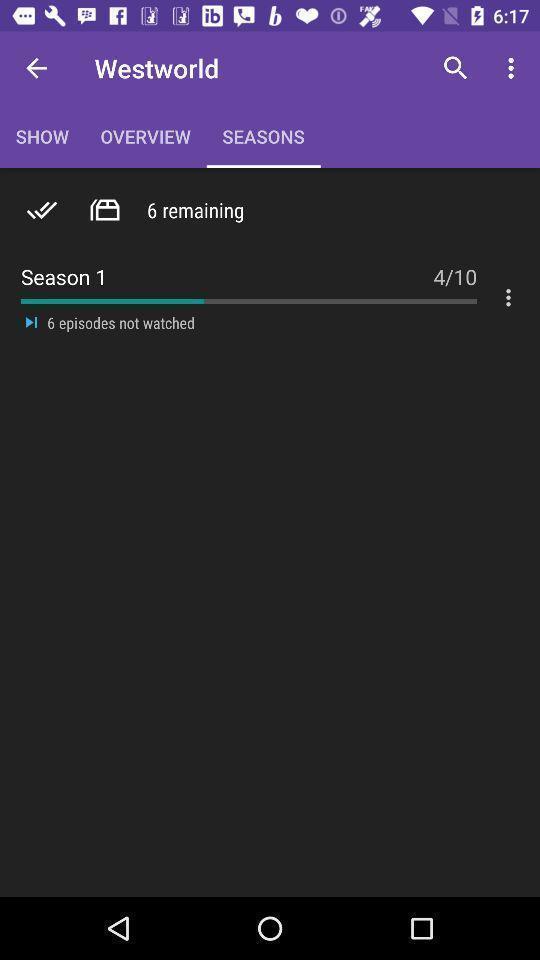Provide a detailed account of this screenshot. Screen showing the seasons tab. 